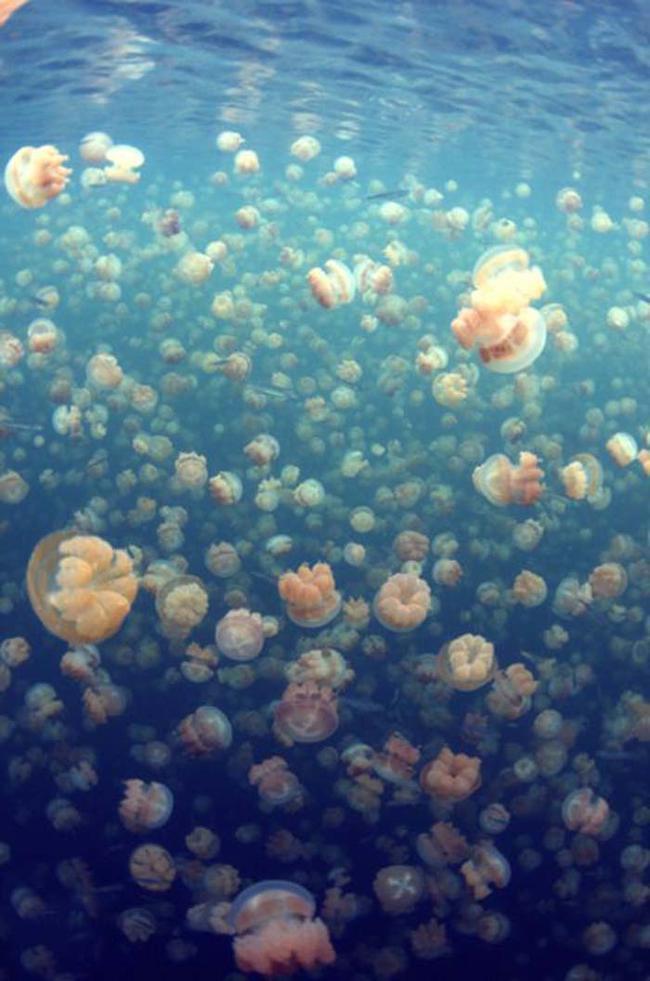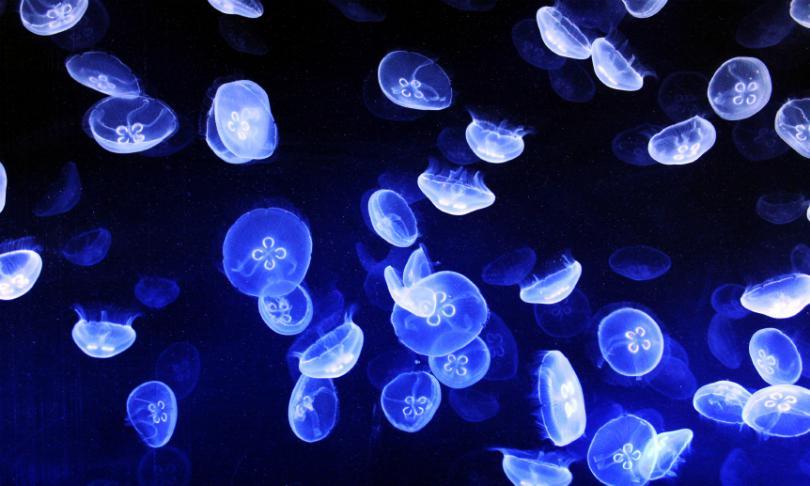The first image is the image on the left, the second image is the image on the right. Considering the images on both sides, is "There are at least one hundred light orange jellyfish in the iamge on the left" valid? Answer yes or no. Yes. The first image is the image on the left, the second image is the image on the right. Considering the images on both sides, is "Jellyfish are the same color in the right and left images." valid? Answer yes or no. No. 